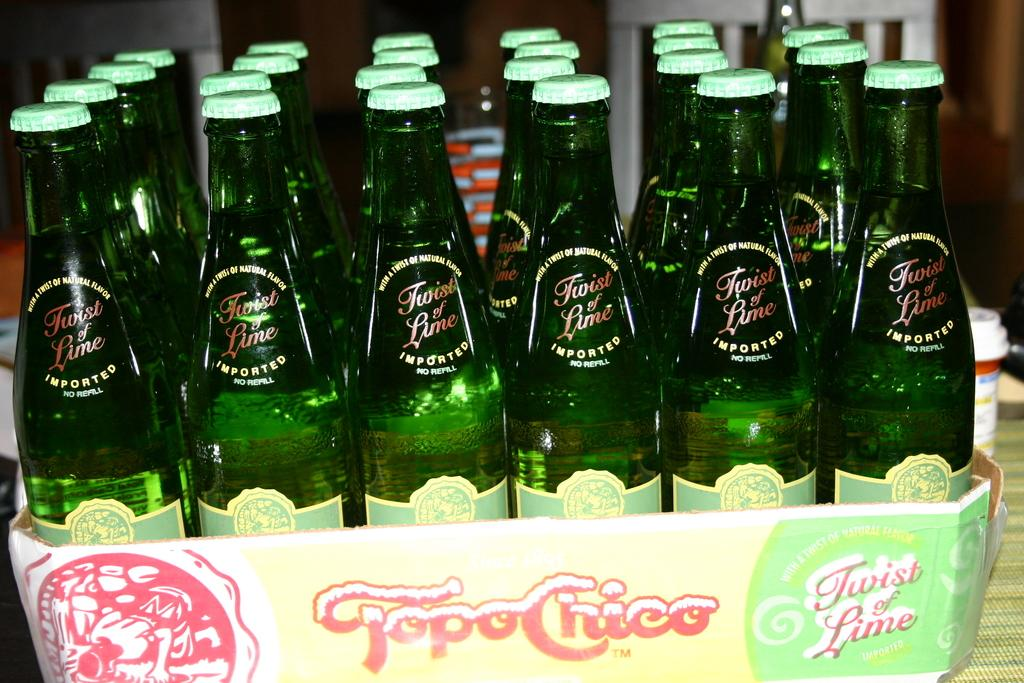<image>
Offer a succinct explanation of the picture presented. The case of Topo Chico was delivered to the restaurant. 